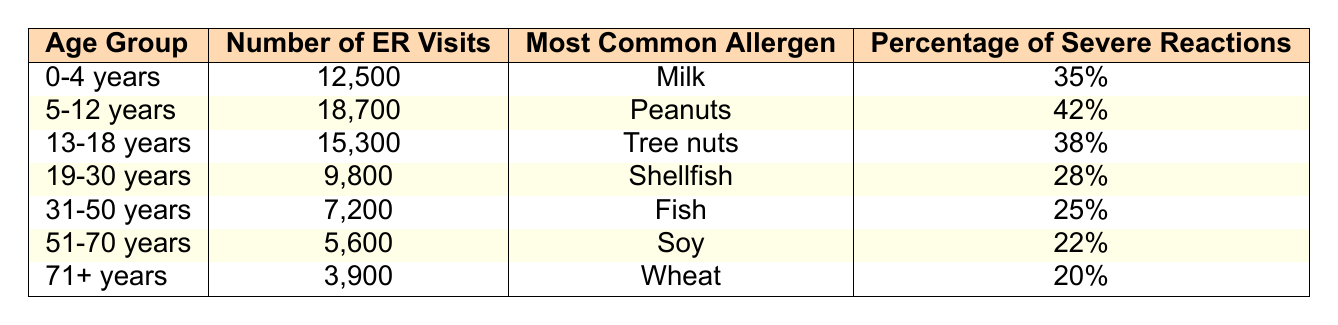What is the most common allergen for the 5-12 years age group? The table lists the most common allergen for the 5-12 years age group as "Peanuts".
Answer: Peanuts How many emergency room visits were reported for the 0-4 years age group? According to the table, the number of ER visits for the 0-4 years age group is 12,500.
Answer: 12,500 Which age group experienced the lowest number of ER visits due to food allergies? The table shows that the 71+ years age group had the lowest number of ER visits, with 3,900 visits.
Answer: 71+ years What percentage of severe reactions was reported in the age group 31-50 years? In the table, the percentage of severe reactions for the 31-50 years age group is listed as 25%.
Answer: 25% How many more ER visits were there for the 5-12 years age group compared to the 71+ years age group? The 5-12 years age group had 18,700 visits and the 71+ years age group had 3,900 visits. The difference is 18,700 - 3,900 = 14,800 visits.
Answer: 14,800 What is the average percentage of severe reactions across all age groups? To find the average, we sum the percentages: 35 + 42 + 38 + 28 + 25 + 22 + 20 = 210. There are 7 age groups, so the average is 210 / 7 = 30%.
Answer: 30% For which age group is Fish the most common allergen? The table indicates that Fish is the most common allergen for the 31-50 years age group.
Answer: 31-50 years Is the percentage of severe reactions higher for the 0-4 years age group or the 51-70 years age group? The 0-4 years age group has a percentage of 35%, while the 51-70 years age group has 22%. Since 35% > 22%, the 0-4 years age group has a higher percentage.
Answer: 0-4 years Which age group has a higher number of ER visits: 13-18 years or 19-30 years? The table shows 15,300 ER visits for the 13-18 years age group and 9,800 for the 19-30 years age group. Since 15,300 > 9,800, the 13-18 years group has more visits.
Answer: 13-18 years What is the total number of ER visits for all age groups combined? Adding all the ER visits: 12,500 + 18,700 + 15,300 + 9,800 + 7,200 + 5,600 + 3,900 = 73,000.
Answer: 73,000 